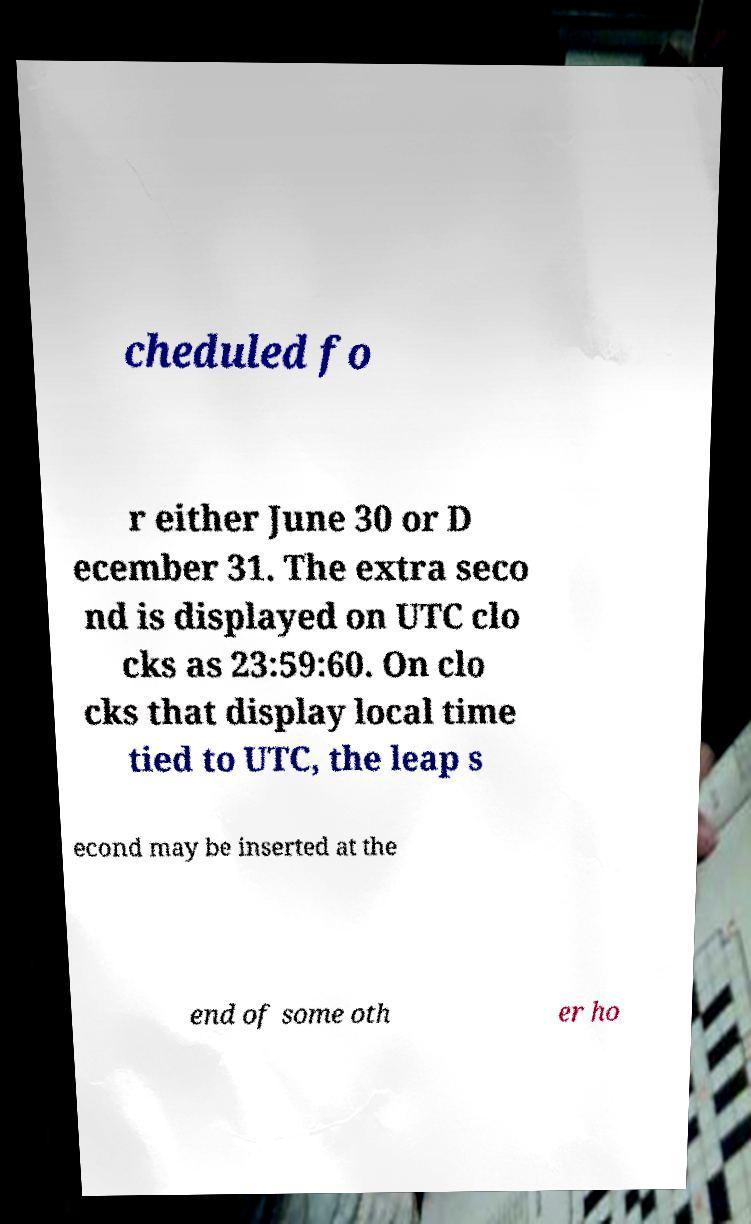For documentation purposes, I need the text within this image transcribed. Could you provide that? cheduled fo r either June 30 or D ecember 31. The extra seco nd is displayed on UTC clo cks as 23:59:60. On clo cks that display local time tied to UTC, the leap s econd may be inserted at the end of some oth er ho 